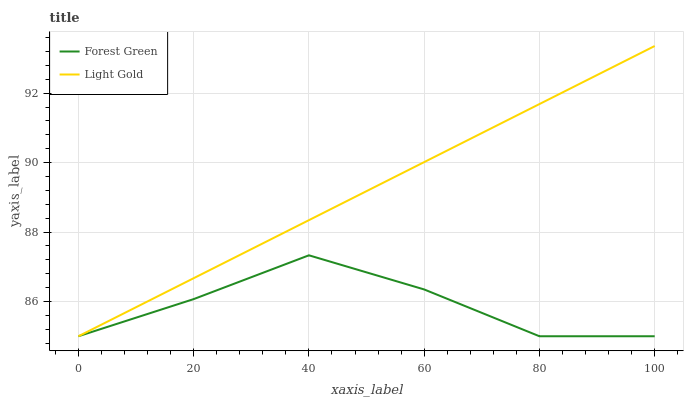Does Light Gold have the minimum area under the curve?
Answer yes or no. No. Is Light Gold the roughest?
Answer yes or no. No. 